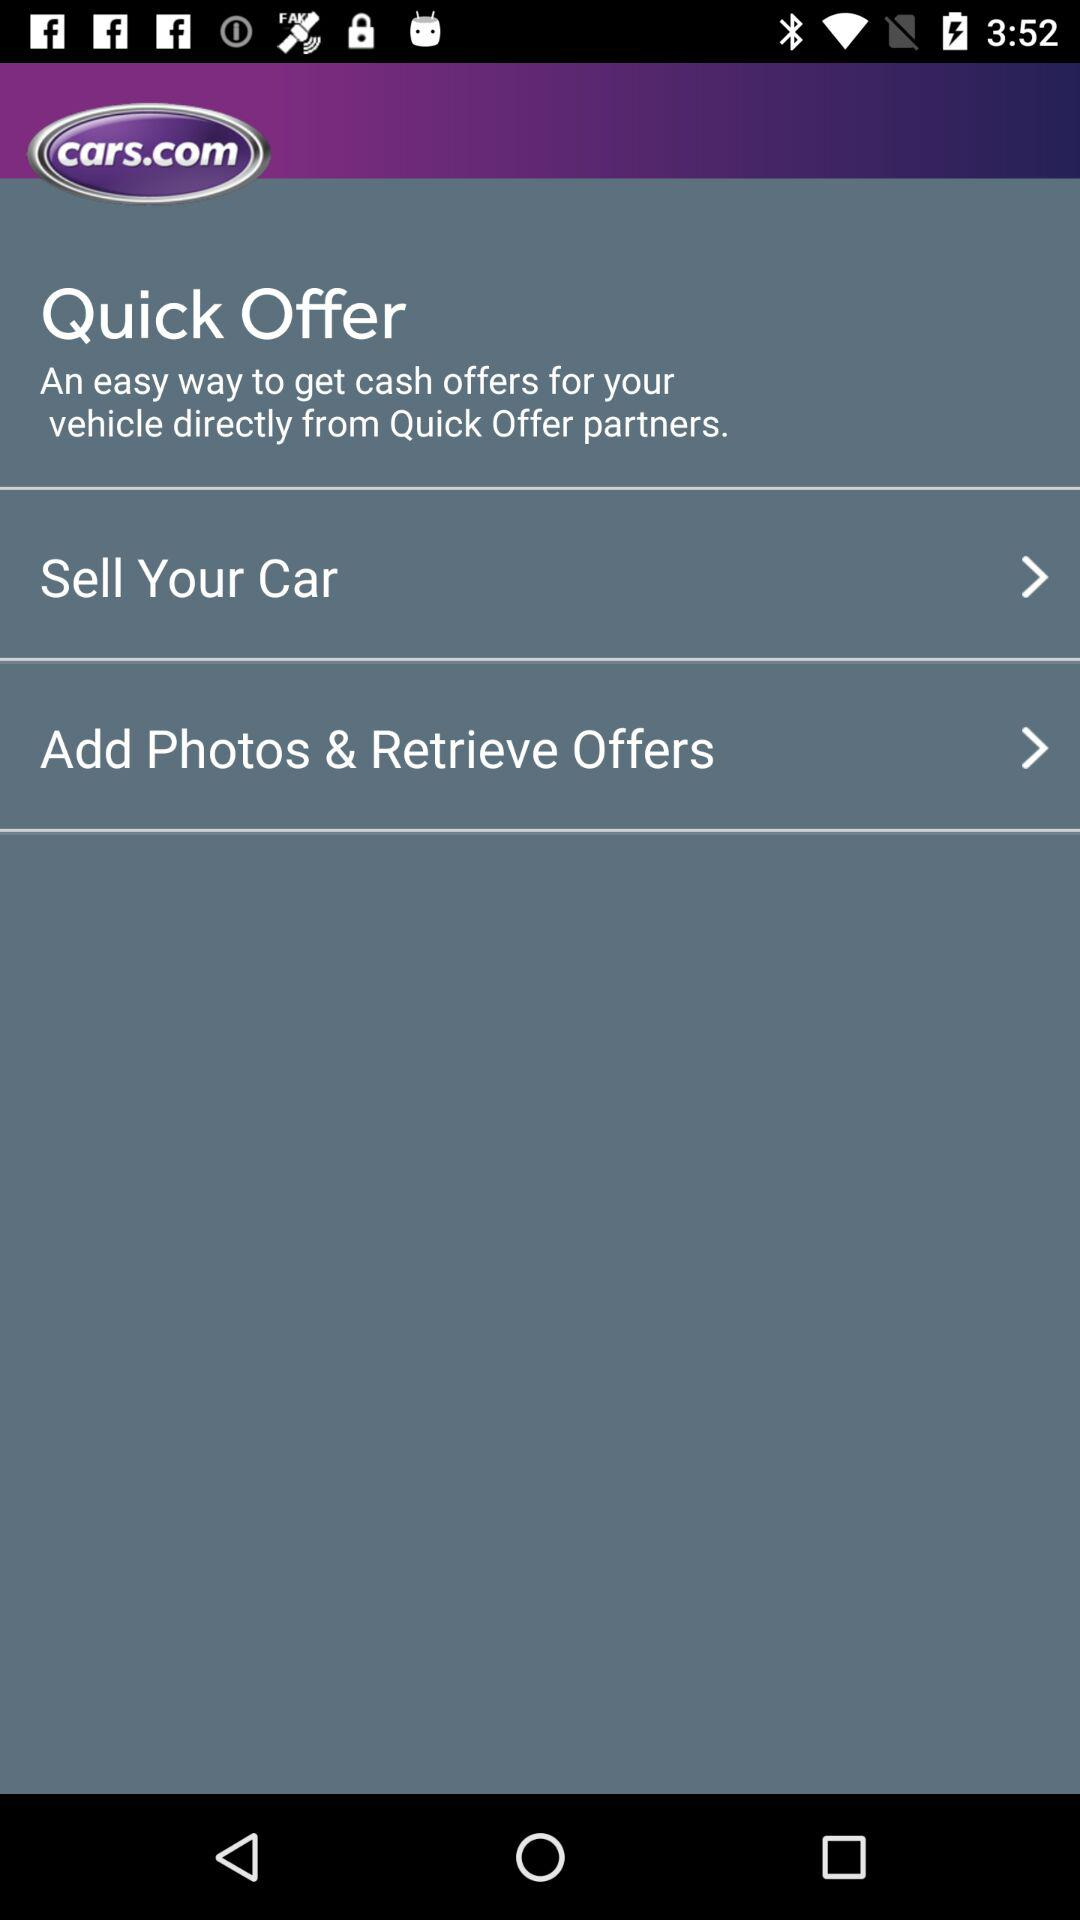What is the application name? The application name is "cars.com". 